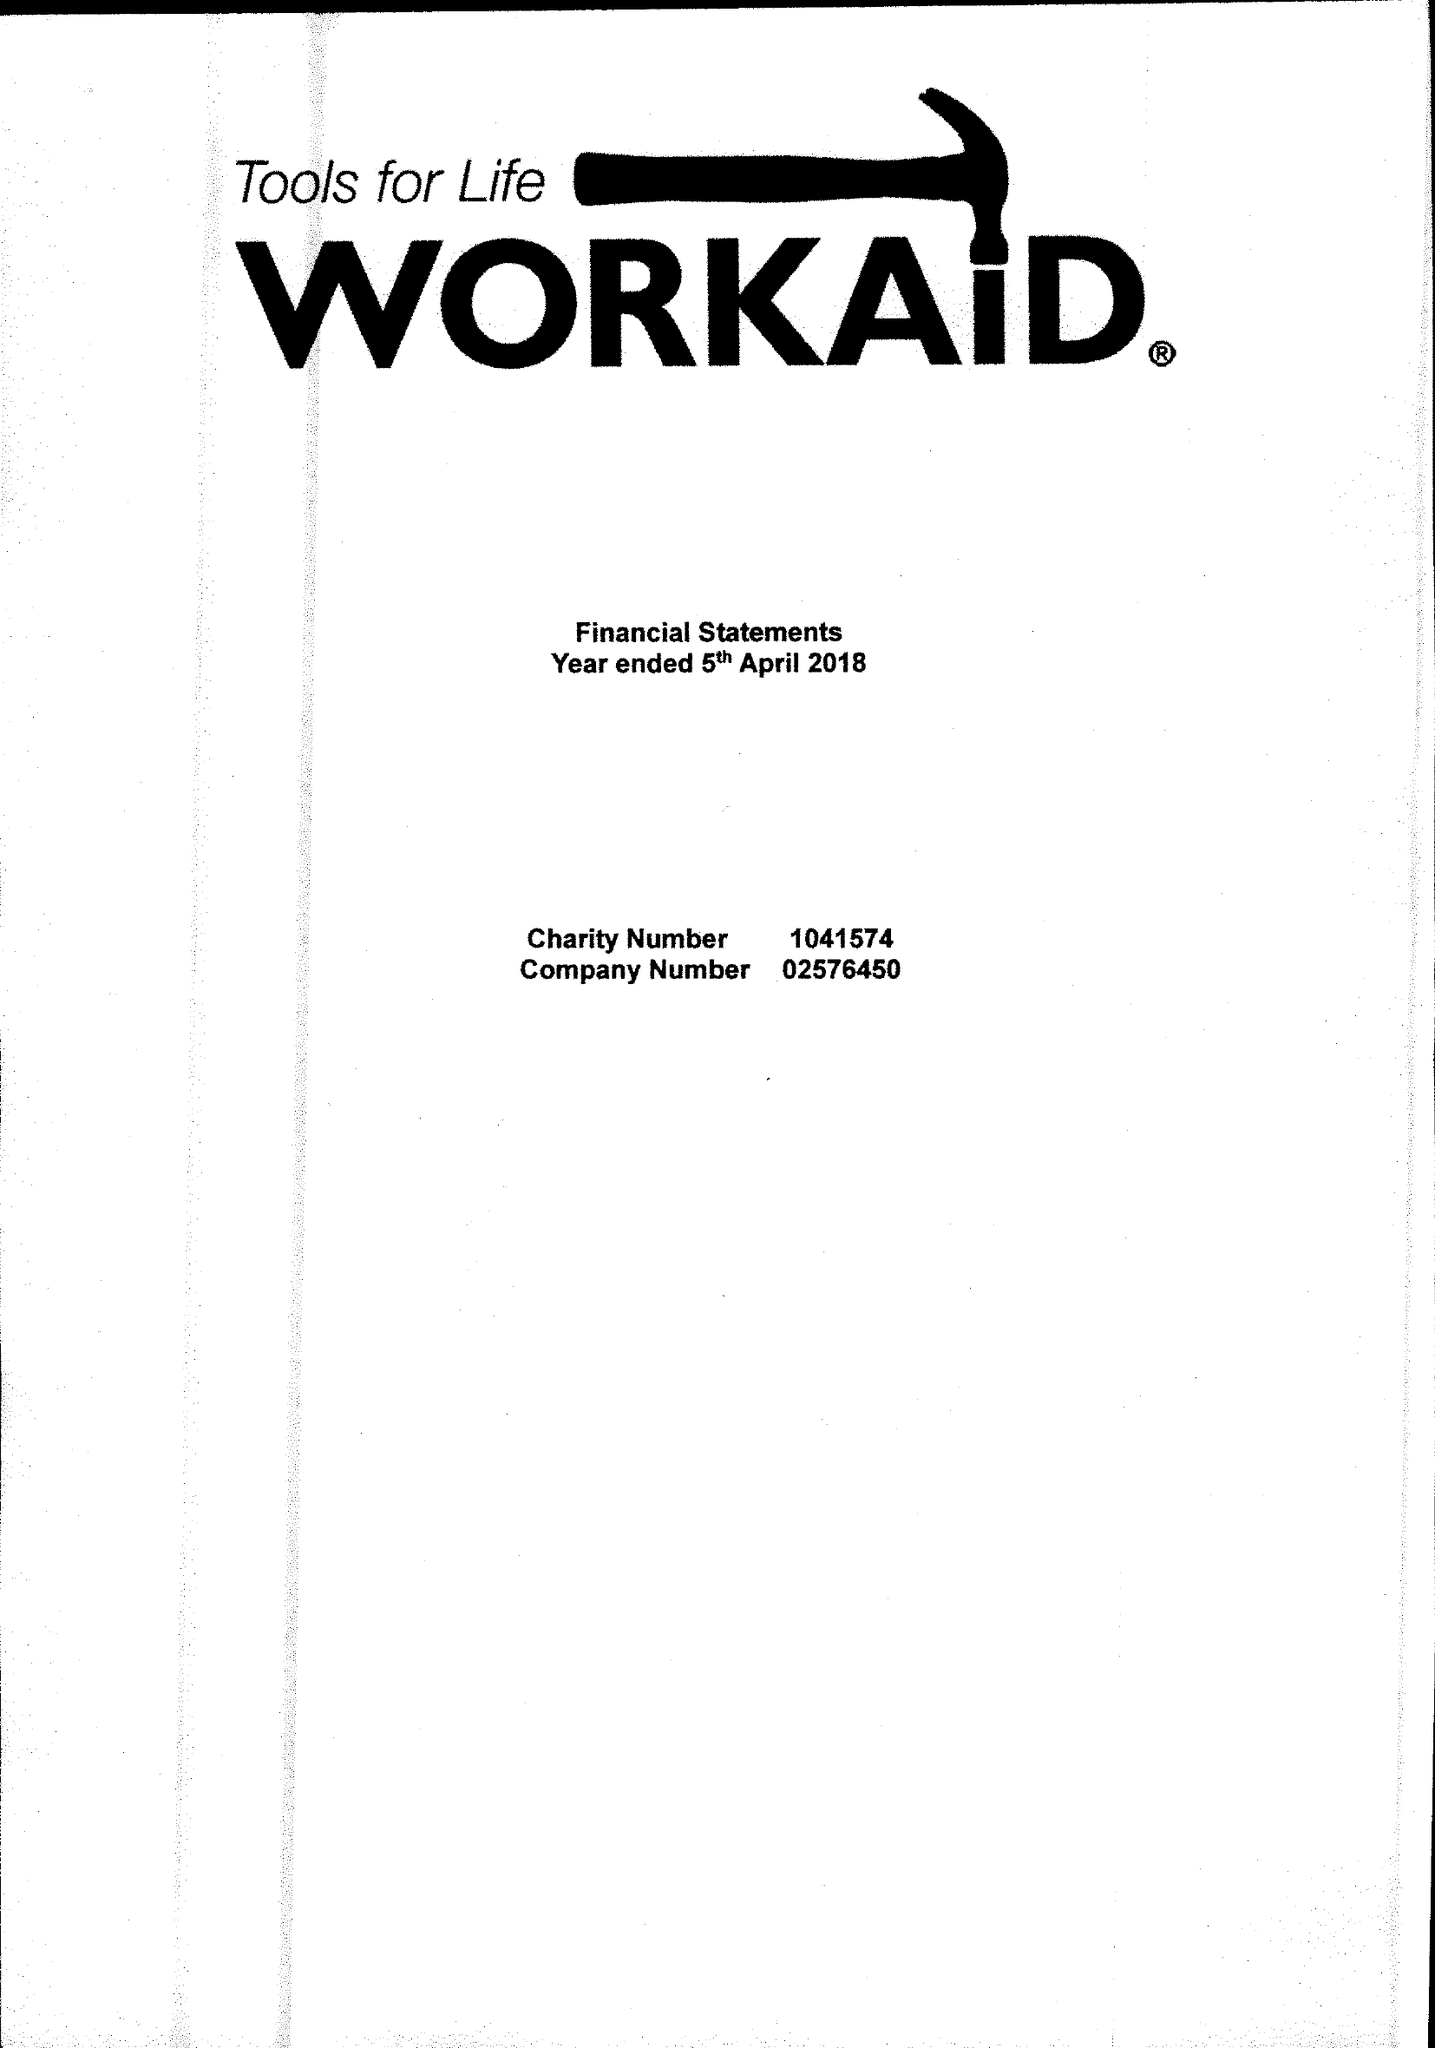What is the value for the address__post_town?
Answer the question using a single word or phrase. CHESHAM 